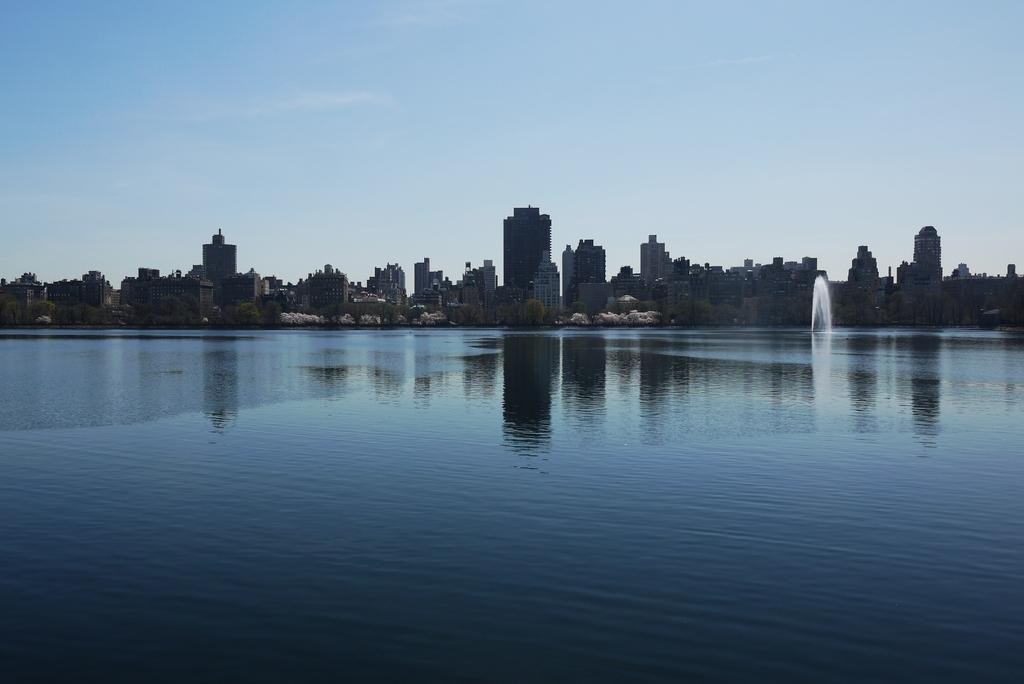What is the primary element visible in the image? There is water in the image. What can be seen in the distance behind the water? There are buildings and trees in the background of the image. What type of furniture can be seen in the jail cell in the image? There is no jail cell or furniture present in the image; it features water with buildings and trees in the background. 